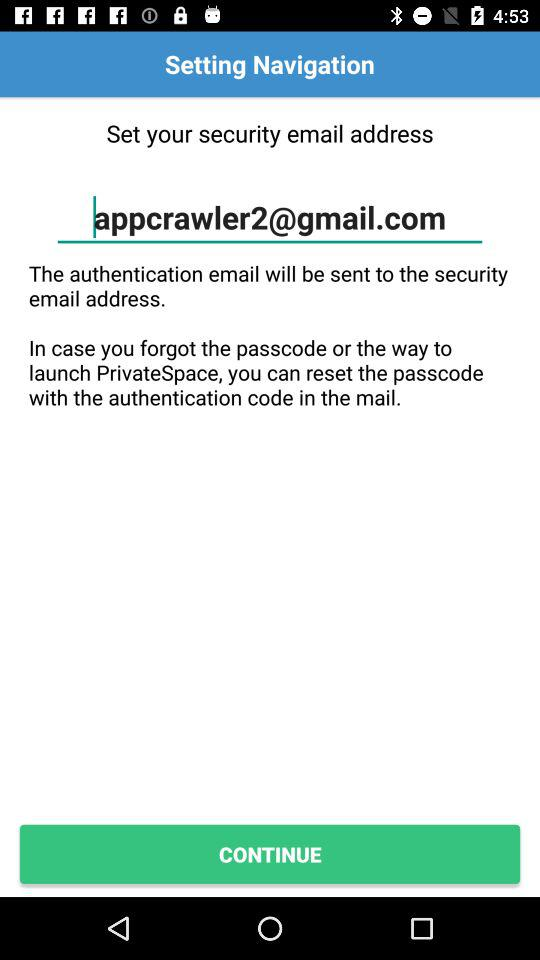What's the security email address? The security email address is appcrawler2@gmail.com. 